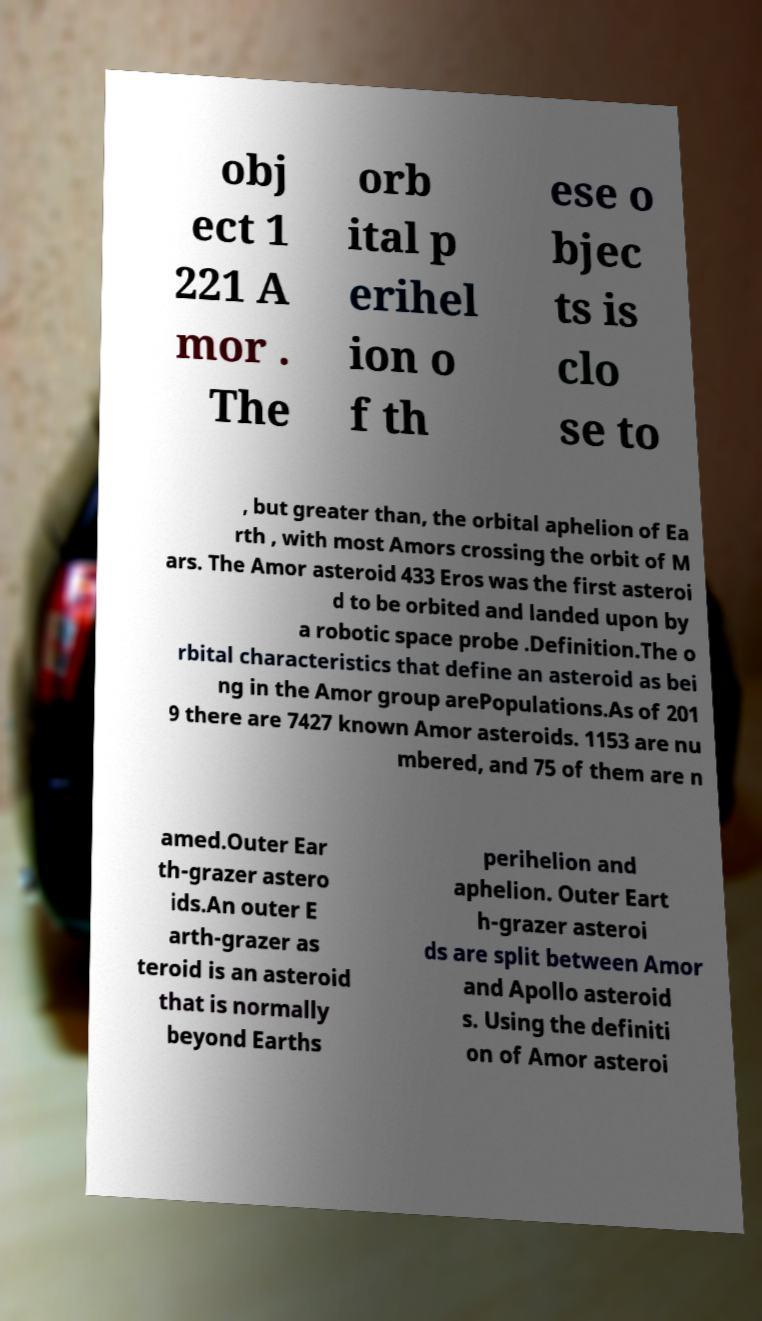There's text embedded in this image that I need extracted. Can you transcribe it verbatim? obj ect 1 221 A mor . The orb ital p erihel ion o f th ese o bjec ts is clo se to , but greater than, the orbital aphelion of Ea rth , with most Amors crossing the orbit of M ars. The Amor asteroid 433 Eros was the first asteroi d to be orbited and landed upon by a robotic space probe .Definition.The o rbital characteristics that define an asteroid as bei ng in the Amor group arePopulations.As of 201 9 there are 7427 known Amor asteroids. 1153 are nu mbered, and 75 of them are n amed.Outer Ear th-grazer astero ids.An outer E arth-grazer as teroid is an asteroid that is normally beyond Earths perihelion and aphelion. Outer Eart h-grazer asteroi ds are split between Amor and Apollo asteroid s. Using the definiti on of Amor asteroi 